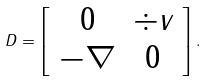<formula> <loc_0><loc_0><loc_500><loc_500>D = \left [ \begin{array} { c c } 0 & \div v \\ - \nabla & 0 \end{array} \right ] .</formula> 